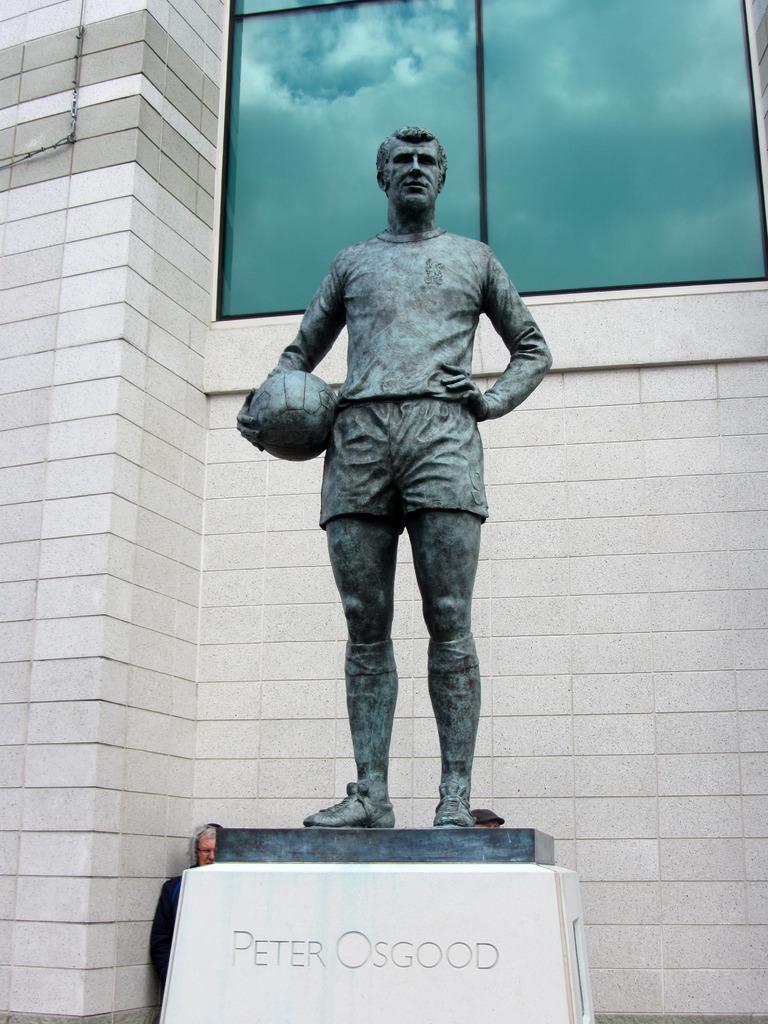Describe this image in one or two sentences. In this image there is a statue of person which is holding a ball visible on small wall, there is a text on the wall at the bottom, behind the wall there is a person, backside of the statue there is the wall, window, on the window I can see the sky. 